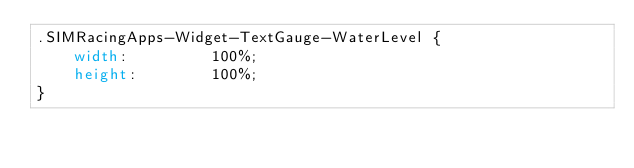<code> <loc_0><loc_0><loc_500><loc_500><_CSS_>.SIMRacingApps-Widget-TextGauge-WaterLevel {
    width:         100%;
    height:        100%;
}
</code> 